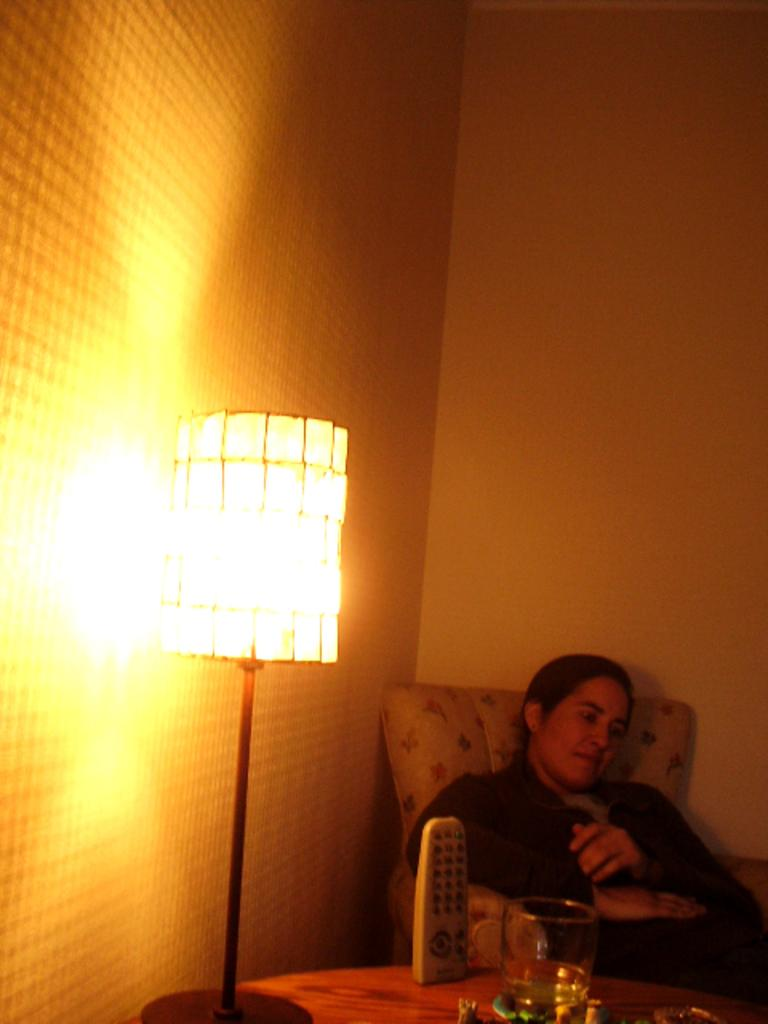What is the person in the image doing? There is a person sitting in the image. What object can be seen near the person? There is a remote in the image. What is on the table in the image? There is a glass on the table in the image. What type of lighting is present in the image? There is a lamp in the image. What is visible in the background of the image? The background of the image includes a wall. What type of arch can be seen in the image? There is no arch present in the image. What is the person in the image doing as a carpenter? The person in the image is not depicted as a carpenter, and there is no activity related to carpentry shown. 